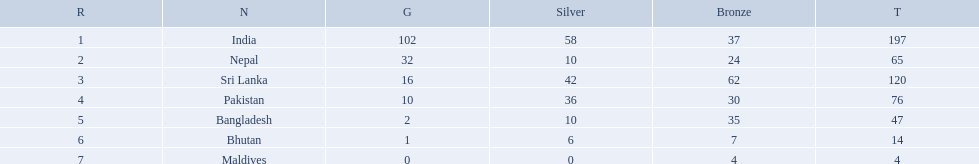What are the totals of medals one in each country? 197, 65, 120, 76, 47, 14, 4. Which of these totals are less than 10? 4. Who won this number of medals? Maldives. What were the total amount won of medals by nations in the 1999 south asian games? 197, 65, 120, 76, 47, 14, 4. Which amount was the lowest? 4. Which nation had this amount? Maldives. 